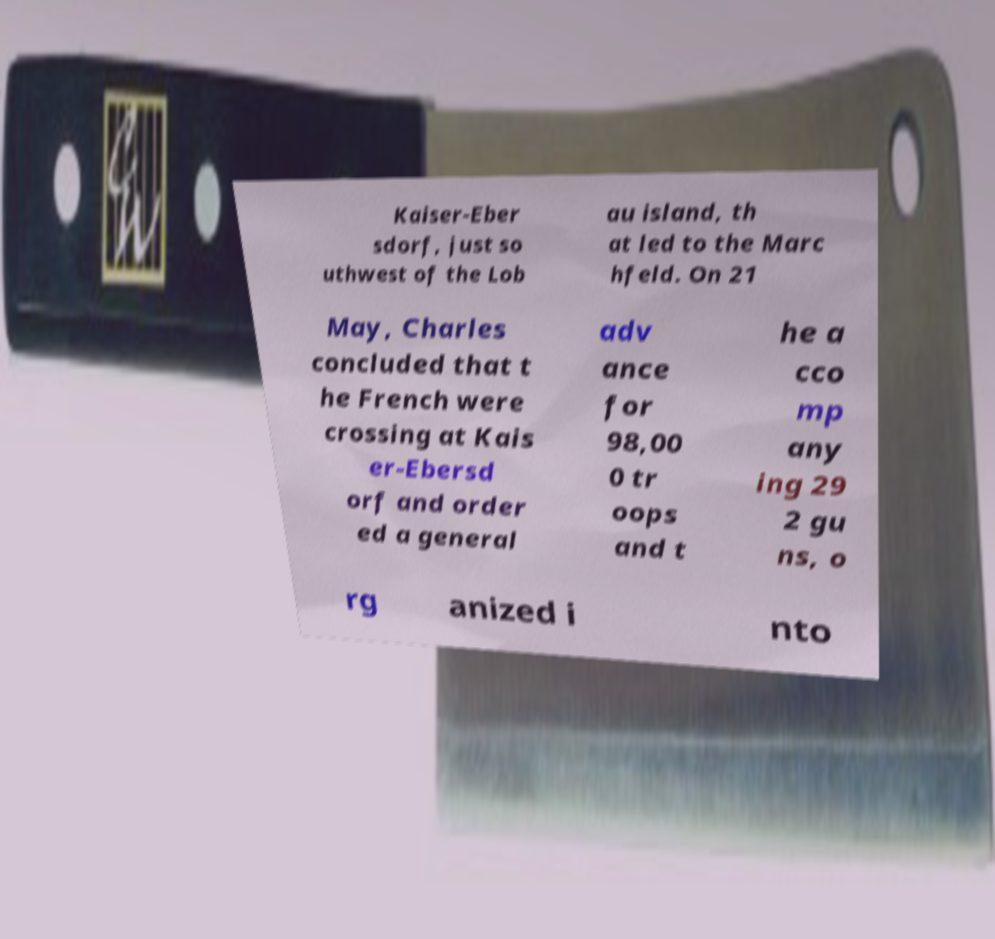Please identify and transcribe the text found in this image. Kaiser-Eber sdorf, just so uthwest of the Lob au island, th at led to the Marc hfeld. On 21 May, Charles concluded that t he French were crossing at Kais er-Ebersd orf and order ed a general adv ance for 98,00 0 tr oops and t he a cco mp any ing 29 2 gu ns, o rg anized i nto 